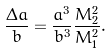Convert formula to latex. <formula><loc_0><loc_0><loc_500><loc_500>\frac { \Delta a } { b } = \frac { a ^ { 3 } } { b ^ { 3 } } \frac { M _ { 2 } ^ { 2 } } { M _ { 1 } ^ { 2 } } .</formula> 